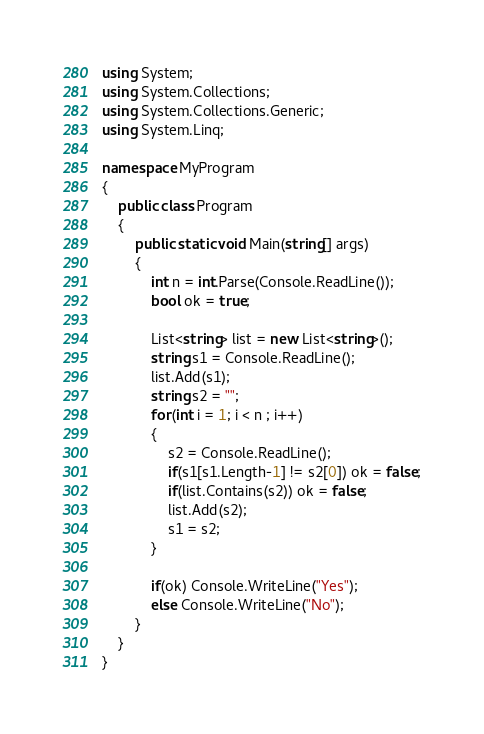<code> <loc_0><loc_0><loc_500><loc_500><_C#_>
using System;
using System.Collections;
using System.Collections.Generic;
using System.Linq;

namespace MyProgram
{
    public class Program
    {	
        public static void Main(string[] args)
        {
            int n = int.Parse(Console.ReadLine());
            bool ok = true;
            
            List<string> list = new List<string>();
            string s1 = Console.ReadLine();
            list.Add(s1);
            string s2 = "";
            for(int i = 1; i < n ; i++)
            {
                s2 = Console.ReadLine();
                if(s1[s1.Length-1] != s2[0]) ok = false;
                if(list.Contains(s2)) ok = false;
                list.Add(s2);
                s1 = s2;
            }
            
            if(ok) Console.WriteLine("Yes");
            else Console.WriteLine("No");
        }
    }
}</code> 